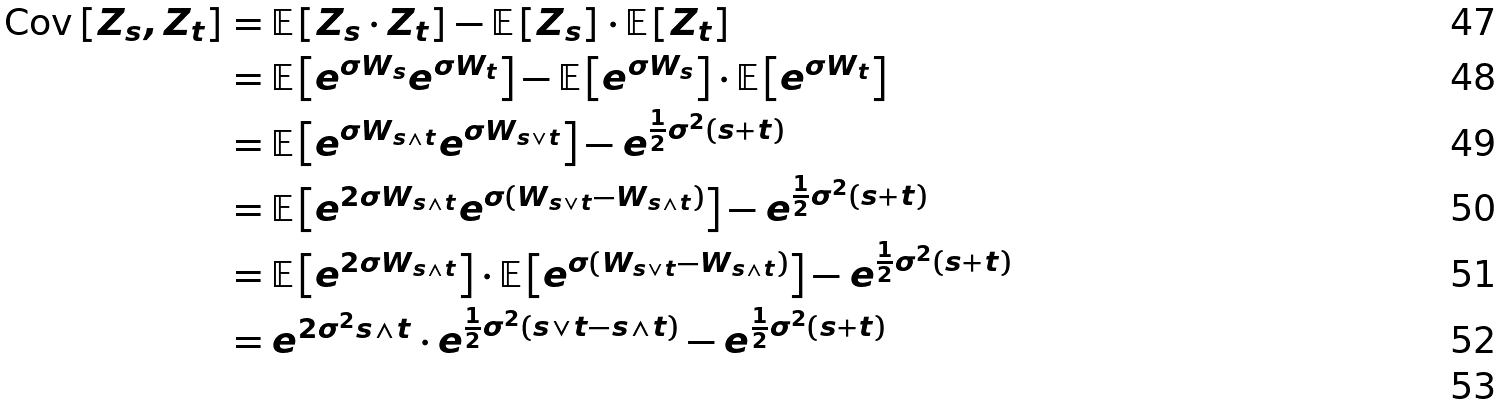<formula> <loc_0><loc_0><loc_500><loc_500>\text {Cov} \left [ Z _ { s } , Z _ { t } \right ] & = \mathbb { E } \left [ Z _ { s } \cdot Z _ { t } \right ] - \mathbb { E } \left [ Z _ { s } \right ] \cdot \mathbb { E } \left [ Z _ { t } \right ] \\ & = \mathbb { E } \left [ e ^ { \sigma W _ { s } } e ^ { \sigma W _ { t } } \right ] - \mathbb { E } \left [ e ^ { \sigma W _ { s } } \right ] \cdot \mathbb { E } \left [ e ^ { \sigma W _ { t } } \right ] \\ & = \mathbb { E } \left [ e ^ { \sigma W _ { s \wedge t } } e ^ { \sigma W _ { s \vee t } } \right ] - e ^ { \frac { 1 } { 2 } \sigma ^ { 2 } ( s + t ) } \\ & = \mathbb { E } \left [ e ^ { 2 \sigma W _ { s \wedge t } } e ^ { \sigma ( W _ { s \vee t } - W _ { s \wedge t } ) } \right ] - e ^ { \frac { 1 } { 2 } \sigma ^ { 2 } ( s + t ) } \\ & = \mathbb { E } \left [ e ^ { 2 \sigma W _ { s \wedge t } } \right ] \cdot \mathbb { E } \left [ e ^ { \sigma ( W _ { s \vee t } - W _ { s \wedge t } ) } \right ] - e ^ { \frac { 1 } { 2 } \sigma ^ { 2 } ( s + t ) } \\ & = e ^ { 2 \sigma ^ { 2 } s \wedge t } \cdot e ^ { \frac { 1 } { 2 } \sigma ^ { 2 } ( s \vee t - s \wedge t ) } - e ^ { \frac { 1 } { 2 } \sigma ^ { 2 } ( s + t ) } \\</formula> 